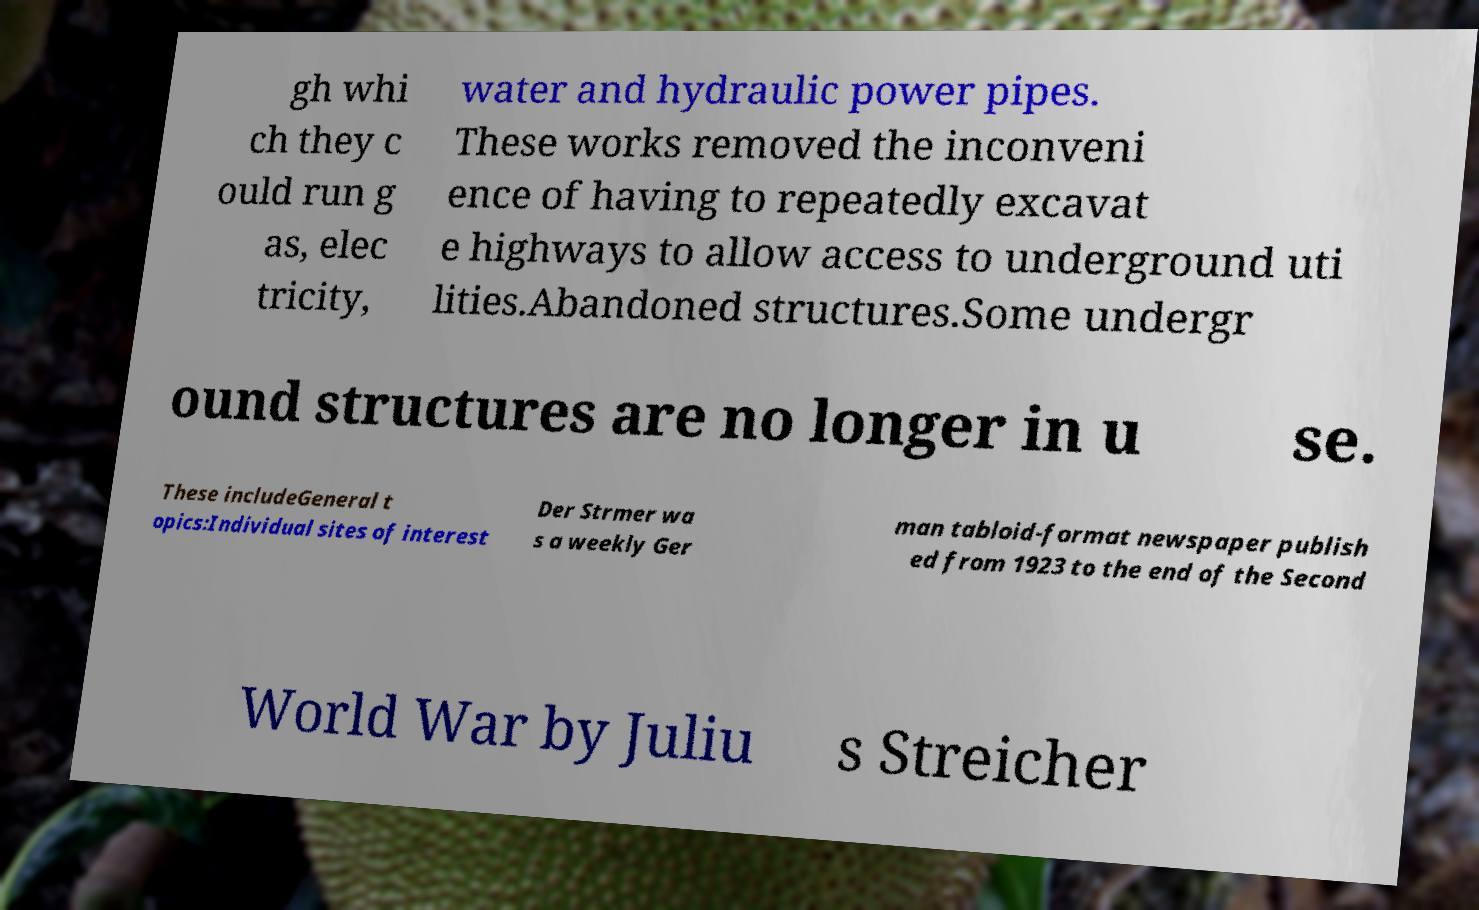There's text embedded in this image that I need extracted. Can you transcribe it verbatim? gh whi ch they c ould run g as, elec tricity, water and hydraulic power pipes. These works removed the inconveni ence of having to repeatedly excavat e highways to allow access to underground uti lities.Abandoned structures.Some undergr ound structures are no longer in u se. These includeGeneral t opics:Individual sites of interest Der Strmer wa s a weekly Ger man tabloid-format newspaper publish ed from 1923 to the end of the Second World War by Juliu s Streicher 